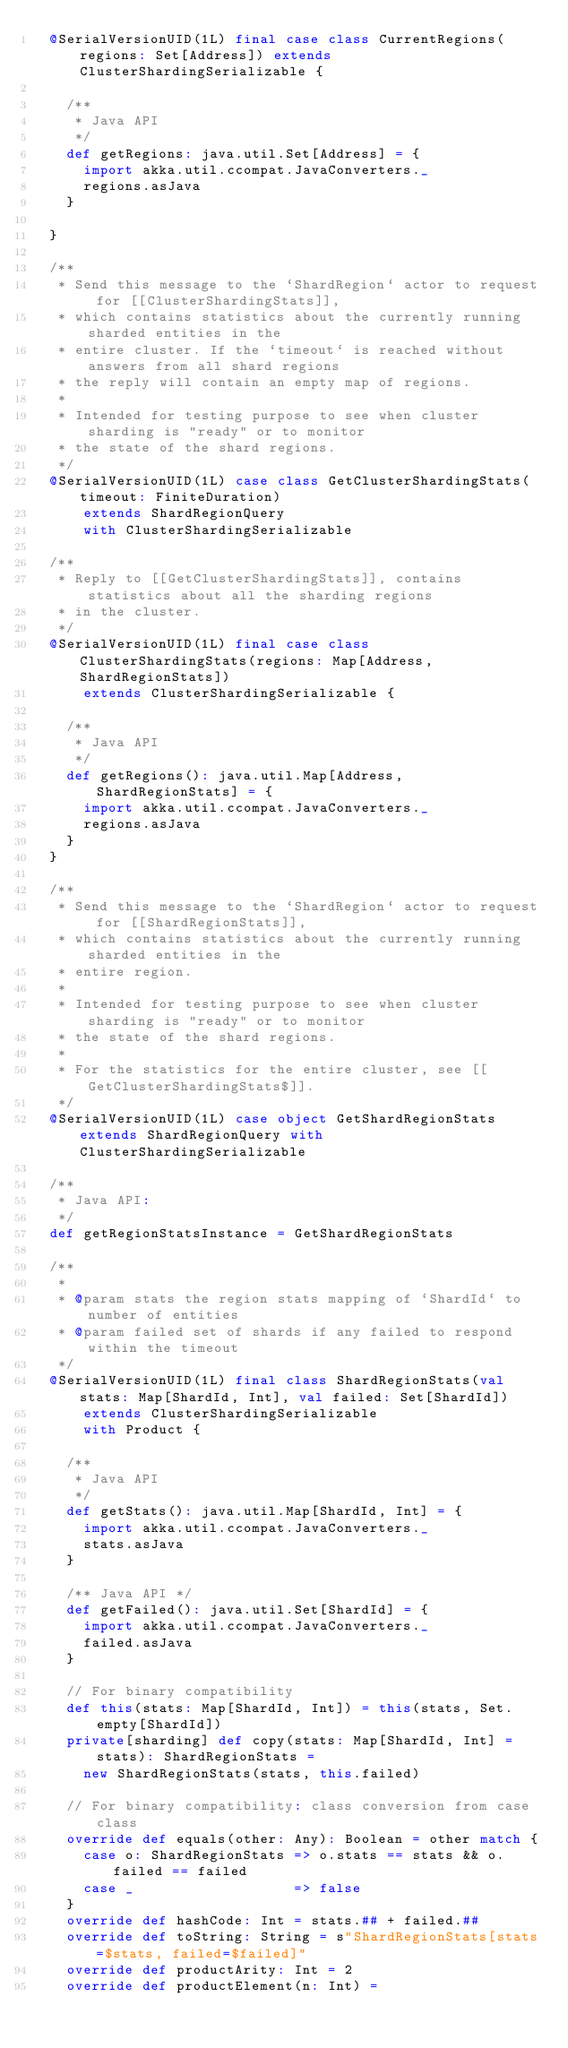Convert code to text. <code><loc_0><loc_0><loc_500><loc_500><_Scala_>  @SerialVersionUID(1L) final case class CurrentRegions(regions: Set[Address]) extends ClusterShardingSerializable {

    /**
     * Java API
     */
    def getRegions: java.util.Set[Address] = {
      import akka.util.ccompat.JavaConverters._
      regions.asJava
    }

  }

  /**
   * Send this message to the `ShardRegion` actor to request for [[ClusterShardingStats]],
   * which contains statistics about the currently running sharded entities in the
   * entire cluster. If the `timeout` is reached without answers from all shard regions
   * the reply will contain an empty map of regions.
   *
   * Intended for testing purpose to see when cluster sharding is "ready" or to monitor
   * the state of the shard regions.
   */
  @SerialVersionUID(1L) case class GetClusterShardingStats(timeout: FiniteDuration)
      extends ShardRegionQuery
      with ClusterShardingSerializable

  /**
   * Reply to [[GetClusterShardingStats]], contains statistics about all the sharding regions
   * in the cluster.
   */
  @SerialVersionUID(1L) final case class ClusterShardingStats(regions: Map[Address, ShardRegionStats])
      extends ClusterShardingSerializable {

    /**
     * Java API
     */
    def getRegions(): java.util.Map[Address, ShardRegionStats] = {
      import akka.util.ccompat.JavaConverters._
      regions.asJava
    }
  }

  /**
   * Send this message to the `ShardRegion` actor to request for [[ShardRegionStats]],
   * which contains statistics about the currently running sharded entities in the
   * entire region.
   *
   * Intended for testing purpose to see when cluster sharding is "ready" or to monitor
   * the state of the shard regions.
   *
   * For the statistics for the entire cluster, see [[GetClusterShardingStats$]].
   */
  @SerialVersionUID(1L) case object GetShardRegionStats extends ShardRegionQuery with ClusterShardingSerializable

  /**
   * Java API:
   */
  def getRegionStatsInstance = GetShardRegionStats

  /**
   *
   * @param stats the region stats mapping of `ShardId` to number of entities
   * @param failed set of shards if any failed to respond within the timeout
   */
  @SerialVersionUID(1L) final class ShardRegionStats(val stats: Map[ShardId, Int], val failed: Set[ShardId])
      extends ClusterShardingSerializable
      with Product {

    /**
     * Java API
     */
    def getStats(): java.util.Map[ShardId, Int] = {
      import akka.util.ccompat.JavaConverters._
      stats.asJava
    }

    /** Java API */
    def getFailed(): java.util.Set[ShardId] = {
      import akka.util.ccompat.JavaConverters._
      failed.asJava
    }

    // For binary compatibility
    def this(stats: Map[ShardId, Int]) = this(stats, Set.empty[ShardId])
    private[sharding] def copy(stats: Map[ShardId, Int] = stats): ShardRegionStats =
      new ShardRegionStats(stats, this.failed)

    // For binary compatibility: class conversion from case class
    override def equals(other: Any): Boolean = other match {
      case o: ShardRegionStats => o.stats == stats && o.failed == failed
      case _                   => false
    }
    override def hashCode: Int = stats.## + failed.##
    override def toString: String = s"ShardRegionStats[stats=$stats, failed=$failed]"
    override def productArity: Int = 2
    override def productElement(n: Int) =</code> 